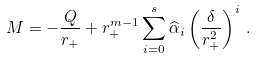<formula> <loc_0><loc_0><loc_500><loc_500>M = - \frac { Q } { r _ { + } } + r _ { + } ^ { m - 1 } \sum _ { i = 0 } ^ { s } \widehat { \alpha } _ { i } \left ( \frac { \delta } { r _ { + } ^ { 2 } } \right ) ^ { i } \, .</formula> 